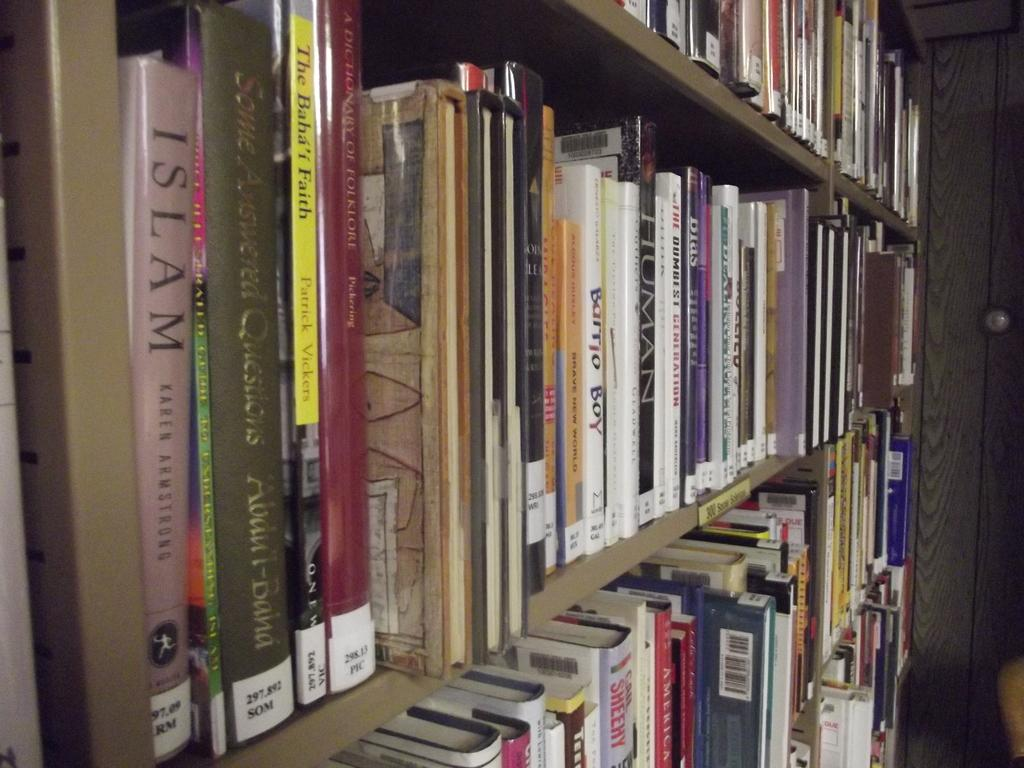Provide a one-sentence caption for the provided image. A large book shelf filled with many books starting with the book, Islam by Karen Armstrong on the middle shelf. 